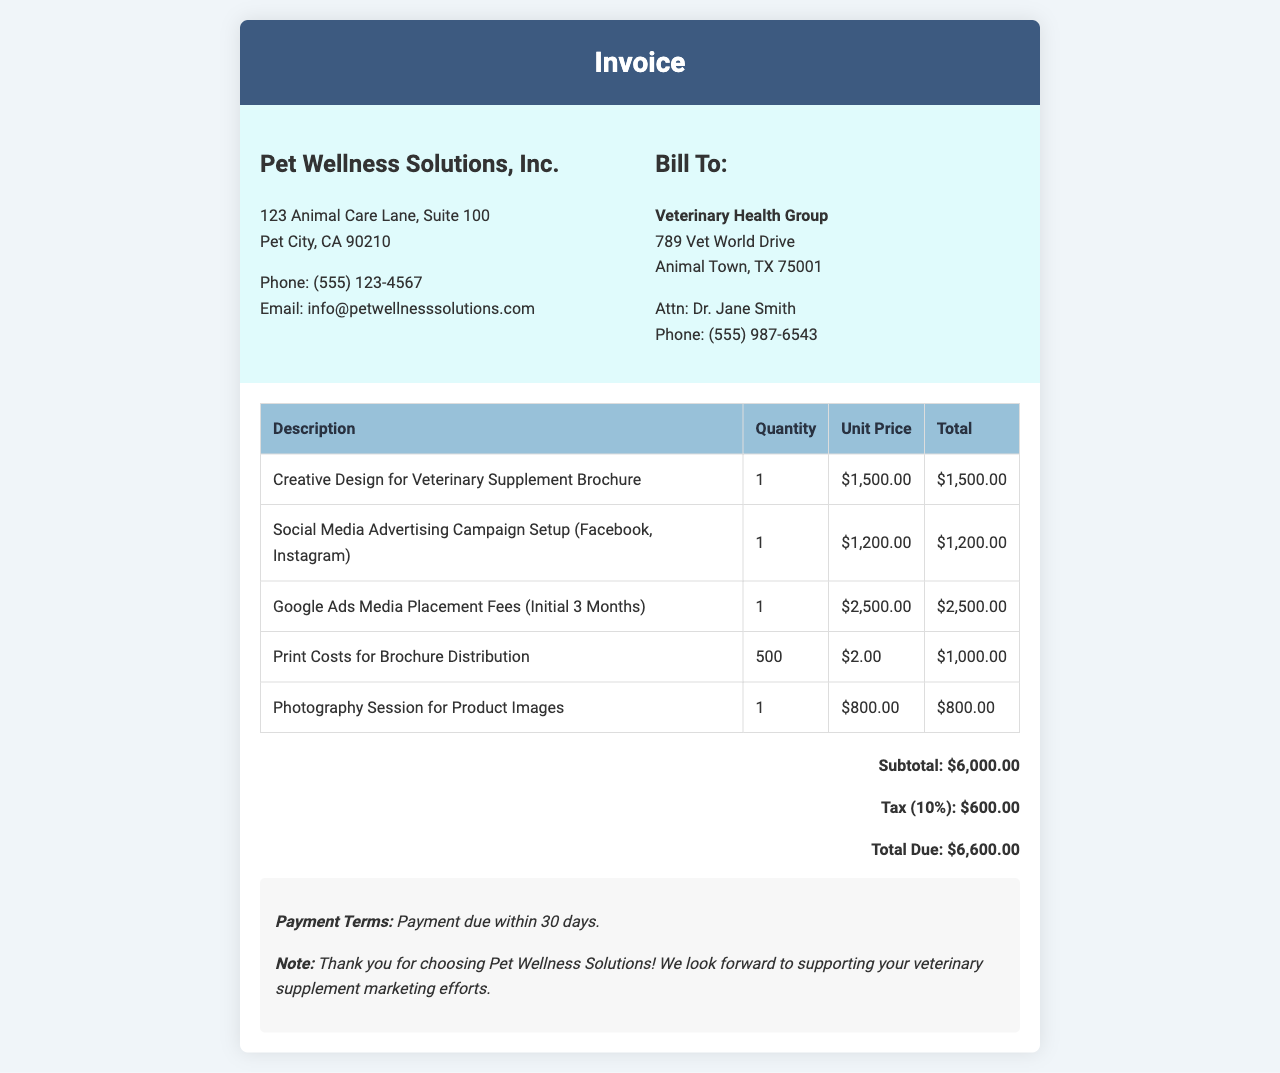What is the total due? The total due is calculated as the subtotal plus tax, which is $6,000.00 + $600.00.
Answer: $6,600.00 Who is the client? The invoice states the client is Veterinary Health Group, along with an address and contact person.
Answer: Veterinary Health Group What is the unit price for photography session? The unit price for the photography session for product images is listed in the document.
Answer: $800.00 What is included in the media placement fees? The media placement fees cover Google Ads for the initial three months as detailed in the invoice.
Answer: Google Ads Media Placement Fees How many brochures were printed? The document indicates the quantity of brochures that were printed for distribution.
Answer: 500 What is the subtotal? The subtotal is the sum of all the costs before tax, listed directly in the document.
Answer: $6,000.00 What are the payment terms? The invoice specifies the payment terms which dictate when payment is required.
Answer: Payment due within 30 days What is the tax rate applied? The tax amount on the invoice can help determine the tax rate by observing the subtotal and total.
Answer: 10% What service was billed for social media setup? The description includes which social media platforms were included in the advertising campaign setup.
Answer: Facebook, Instagram 